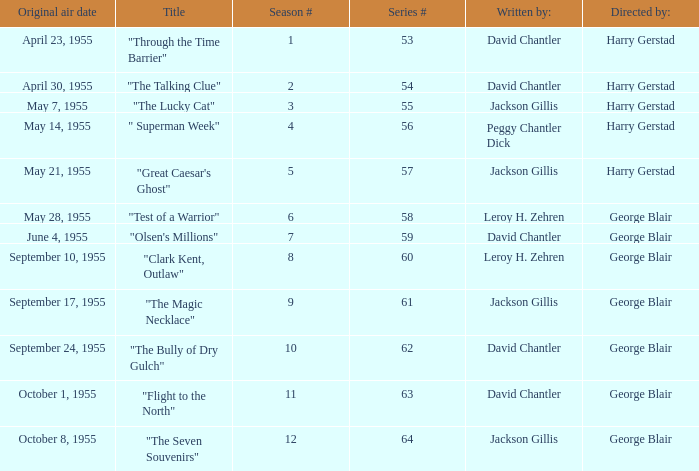Could you parse the entire table? {'header': ['Original air date', 'Title', 'Season #', 'Series #', 'Written by:', 'Directed by:'], 'rows': [['April 23, 1955', '"Through the Time Barrier"', '1', '53', 'David Chantler', 'Harry Gerstad'], ['April 30, 1955', '"The Talking Clue"', '2', '54', 'David Chantler', 'Harry Gerstad'], ['May 7, 1955', '"The Lucky Cat"', '3', '55', 'Jackson Gillis', 'Harry Gerstad'], ['May 14, 1955', '" Superman Week"', '4', '56', 'Peggy Chantler Dick', 'Harry Gerstad'], ['May 21, 1955', '"Great Caesar\'s Ghost"', '5', '57', 'Jackson Gillis', 'Harry Gerstad'], ['May 28, 1955', '"Test of a Warrior"', '6', '58', 'Leroy H. Zehren', 'George Blair'], ['June 4, 1955', '"Olsen\'s Millions"', '7', '59', 'David Chantler', 'George Blair'], ['September 10, 1955', '"Clark Kent, Outlaw"', '8', '60', 'Leroy H. Zehren', 'George Blair'], ['September 17, 1955', '"The Magic Necklace"', '9', '61', 'Jackson Gillis', 'George Blair'], ['September 24, 1955', '"The Bully of Dry Gulch"', '10', '62', 'David Chantler', 'George Blair'], ['October 1, 1955', '"Flight to the North"', '11', '63', 'David Chantler', 'George Blair'], ['October 8, 1955', '"The Seven Souvenirs"', '12', '64', 'Jackson Gillis', 'George Blair']]} Who was "The Magic Necklace" written by? Jackson Gillis. 